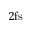<formula> <loc_0><loc_0><loc_500><loc_500>2 f s</formula> 